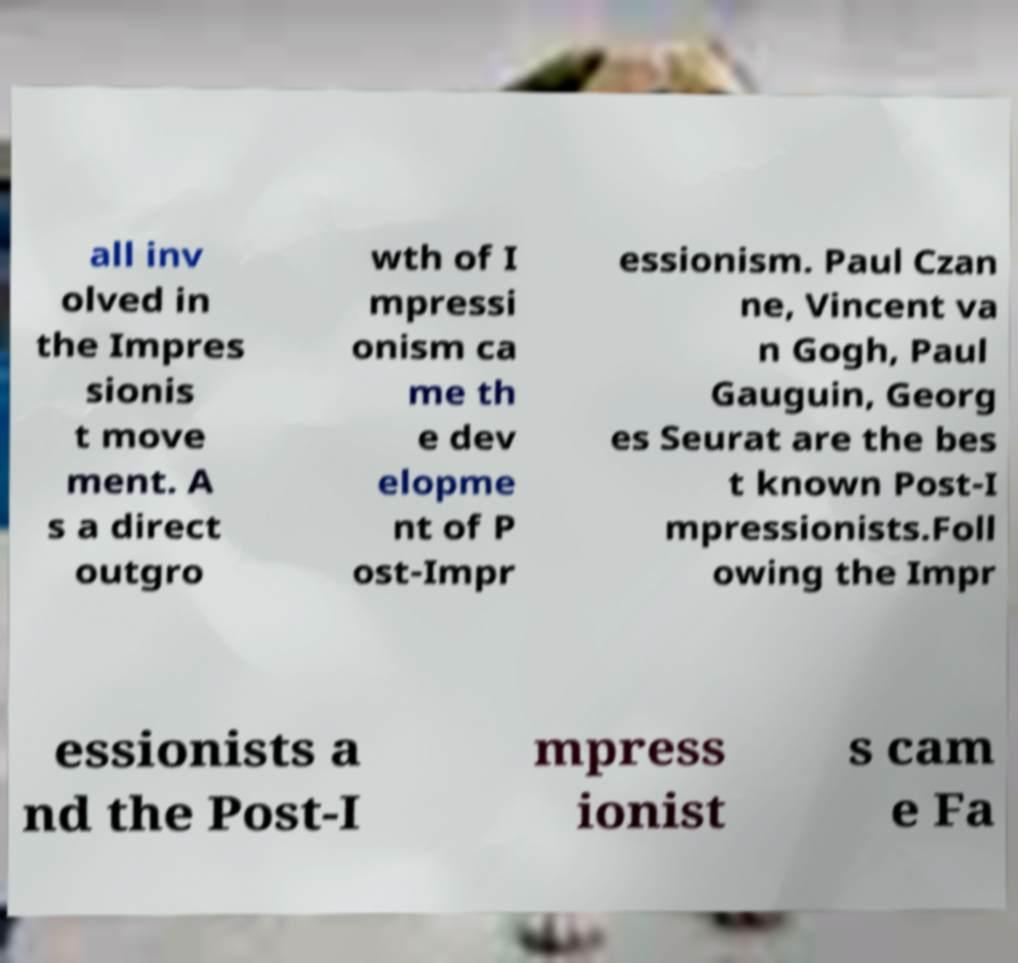Please identify and transcribe the text found in this image. all inv olved in the Impres sionis t move ment. A s a direct outgro wth of I mpressi onism ca me th e dev elopme nt of P ost-Impr essionism. Paul Czan ne, Vincent va n Gogh, Paul Gauguin, Georg es Seurat are the bes t known Post-I mpressionists.Foll owing the Impr essionists a nd the Post-I mpress ionist s cam e Fa 